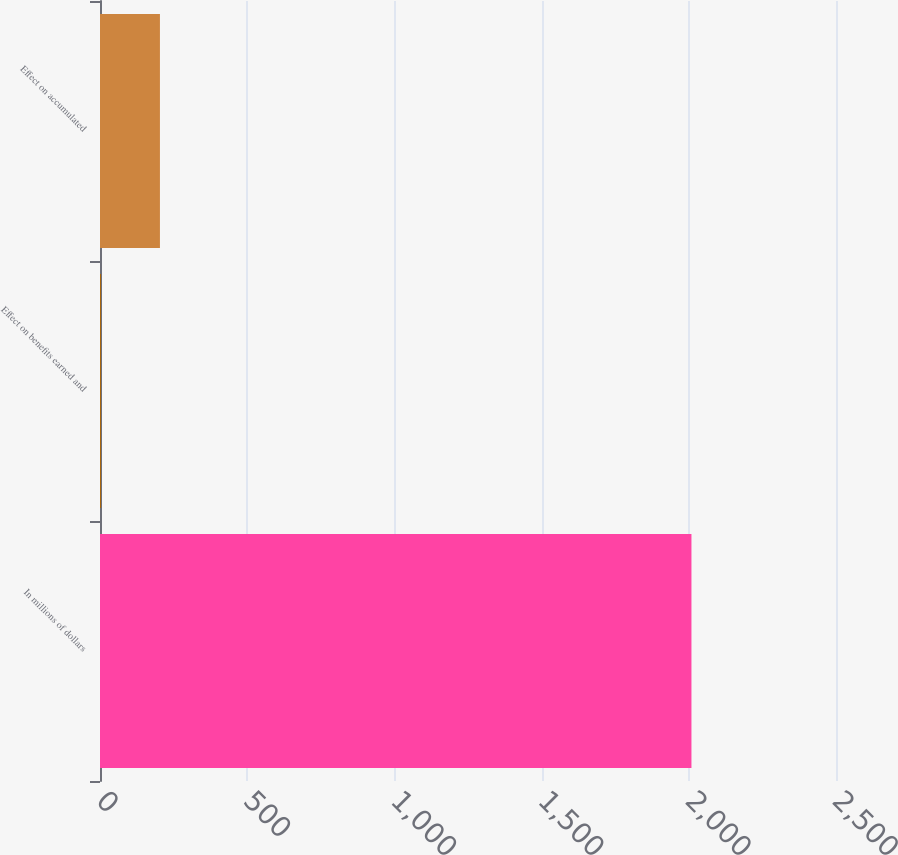Convert chart. <chart><loc_0><loc_0><loc_500><loc_500><bar_chart><fcel>In millions of dollars<fcel>Effect on benefits earned and<fcel>Effect on accumulated<nl><fcel>2009<fcel>3<fcel>203.6<nl></chart> 